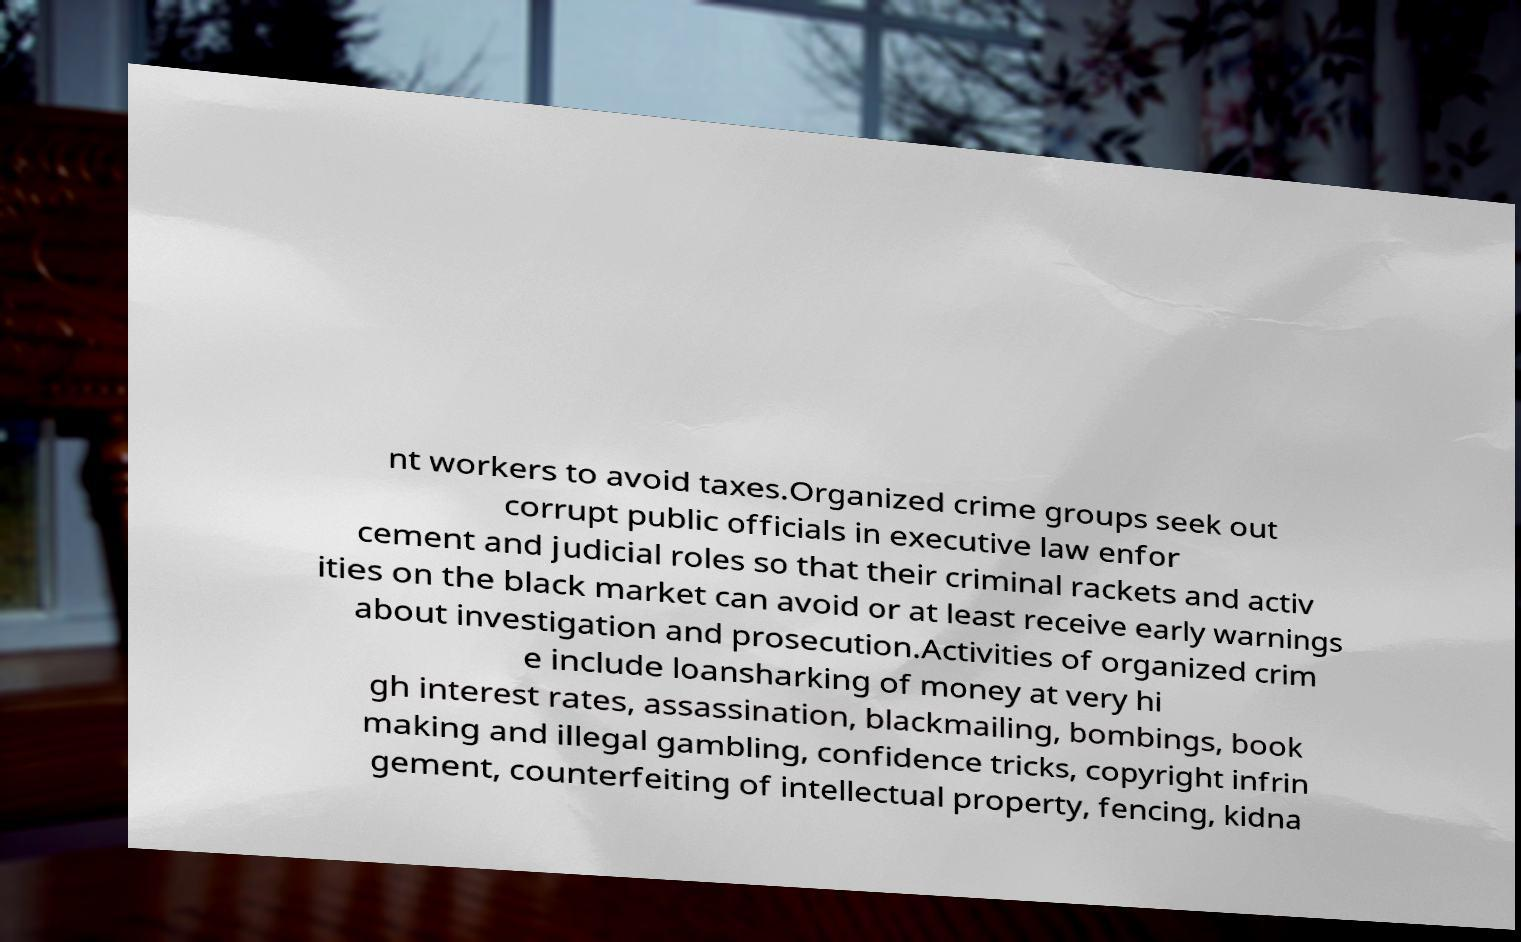I need the written content from this picture converted into text. Can you do that? nt workers to avoid taxes.Organized crime groups seek out corrupt public officials in executive law enfor cement and judicial roles so that their criminal rackets and activ ities on the black market can avoid or at least receive early warnings about investigation and prosecution.Activities of organized crim e include loansharking of money at very hi gh interest rates, assassination, blackmailing, bombings, book making and illegal gambling, confidence tricks, copyright infrin gement, counterfeiting of intellectual property, fencing, kidna 